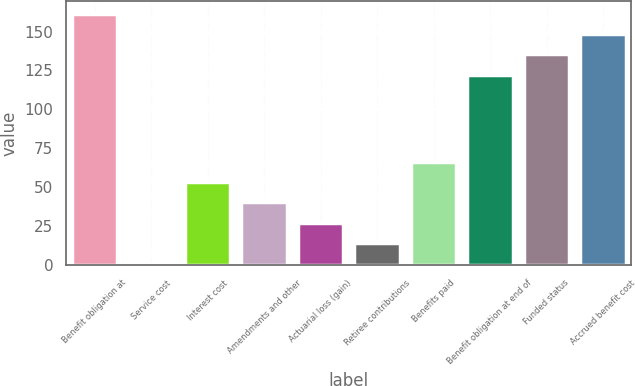<chart> <loc_0><loc_0><loc_500><loc_500><bar_chart><fcel>Benefit obligation at<fcel>Service cost<fcel>Interest cost<fcel>Amendments and other<fcel>Actuarial loss (gain)<fcel>Retiree contributions<fcel>Benefits paid<fcel>Benefit obligation at end of<fcel>Funded status<fcel>Accrued benefit cost<nl><fcel>161.37<fcel>1.3<fcel>53.26<fcel>40.27<fcel>27.28<fcel>14.29<fcel>66.25<fcel>122.4<fcel>135.39<fcel>148.38<nl></chart> 